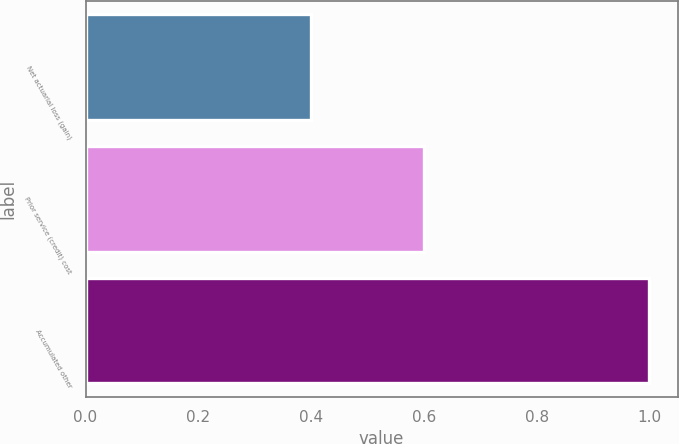<chart> <loc_0><loc_0><loc_500><loc_500><bar_chart><fcel>Net actuarial loss (gain)<fcel>Prior service (credit) cost<fcel>Accumulated other<nl><fcel>0.4<fcel>0.6<fcel>1<nl></chart> 